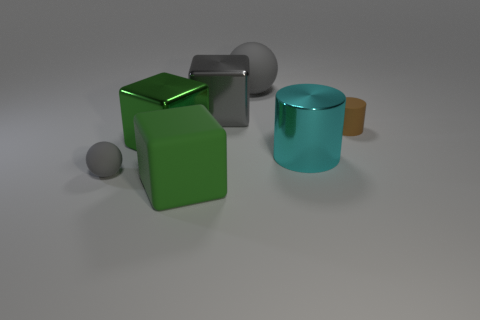Add 2 tiny red blocks. How many objects exist? 9 Subtract all spheres. How many objects are left? 5 Add 5 green rubber blocks. How many green rubber blocks are left? 6 Add 3 large cyan cylinders. How many large cyan cylinders exist? 4 Subtract 0 blue blocks. How many objects are left? 7 Subtract all green matte things. Subtract all gray blocks. How many objects are left? 5 